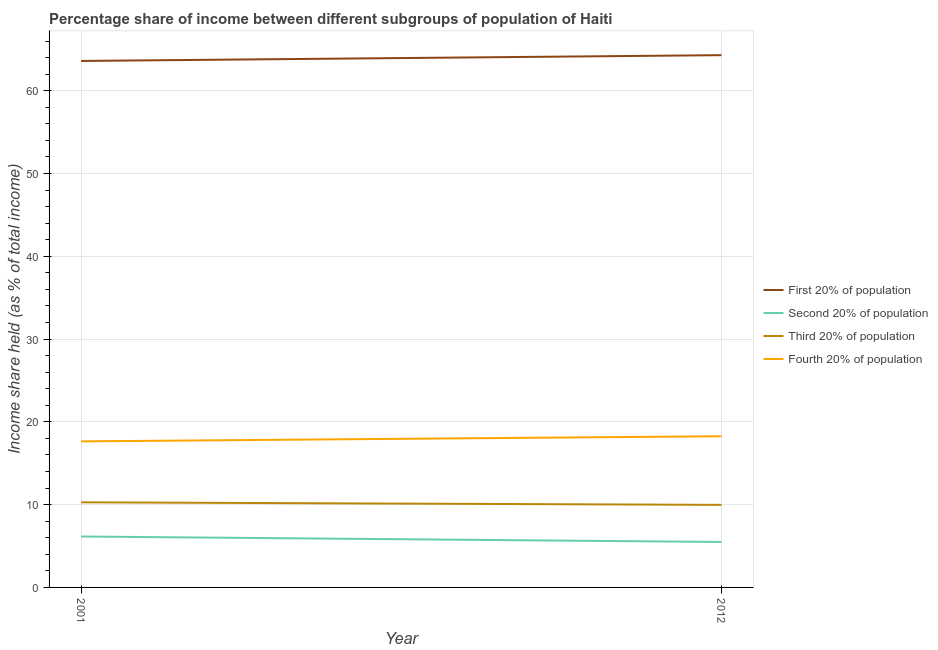Is the number of lines equal to the number of legend labels?
Your answer should be very brief. Yes. What is the share of the income held by first 20% of the population in 2001?
Offer a very short reply. 63.59. Across all years, what is the maximum share of the income held by third 20% of the population?
Your response must be concise. 10.28. Across all years, what is the minimum share of the income held by fourth 20% of the population?
Offer a terse response. 17.64. In which year was the share of the income held by fourth 20% of the population maximum?
Make the answer very short. 2012. In which year was the share of the income held by first 20% of the population minimum?
Keep it short and to the point. 2001. What is the total share of the income held by second 20% of the population in the graph?
Provide a succinct answer. 11.64. What is the difference between the share of the income held by third 20% of the population in 2001 and that in 2012?
Your response must be concise. 0.31. What is the difference between the share of the income held by first 20% of the population in 2001 and the share of the income held by fourth 20% of the population in 2012?
Your answer should be very brief. 45.33. What is the average share of the income held by third 20% of the population per year?
Make the answer very short. 10.12. In the year 2001, what is the difference between the share of the income held by second 20% of the population and share of the income held by first 20% of the population?
Offer a terse response. -57.44. In how many years, is the share of the income held by second 20% of the population greater than 60 %?
Keep it short and to the point. 0. What is the ratio of the share of the income held by second 20% of the population in 2001 to that in 2012?
Make the answer very short. 1.12. Is it the case that in every year, the sum of the share of the income held by first 20% of the population and share of the income held by second 20% of the population is greater than the share of the income held by third 20% of the population?
Make the answer very short. Yes. Does the share of the income held by second 20% of the population monotonically increase over the years?
Your answer should be very brief. No. How many lines are there?
Your answer should be compact. 4. How many years are there in the graph?
Provide a short and direct response. 2. Does the graph contain grids?
Offer a terse response. Yes. How many legend labels are there?
Offer a very short reply. 4. What is the title of the graph?
Provide a short and direct response. Percentage share of income between different subgroups of population of Haiti. What is the label or title of the Y-axis?
Make the answer very short. Income share held (as % of total income). What is the Income share held (as % of total income) of First 20% of population in 2001?
Your answer should be compact. 63.59. What is the Income share held (as % of total income) in Second 20% of population in 2001?
Provide a short and direct response. 6.15. What is the Income share held (as % of total income) of Third 20% of population in 2001?
Give a very brief answer. 10.28. What is the Income share held (as % of total income) in Fourth 20% of population in 2001?
Offer a very short reply. 17.64. What is the Income share held (as % of total income) in First 20% of population in 2012?
Offer a terse response. 64.29. What is the Income share held (as % of total income) of Second 20% of population in 2012?
Give a very brief answer. 5.49. What is the Income share held (as % of total income) in Third 20% of population in 2012?
Give a very brief answer. 9.97. What is the Income share held (as % of total income) in Fourth 20% of population in 2012?
Offer a very short reply. 18.26. Across all years, what is the maximum Income share held (as % of total income) in First 20% of population?
Keep it short and to the point. 64.29. Across all years, what is the maximum Income share held (as % of total income) of Second 20% of population?
Your answer should be very brief. 6.15. Across all years, what is the maximum Income share held (as % of total income) in Third 20% of population?
Your response must be concise. 10.28. Across all years, what is the maximum Income share held (as % of total income) in Fourth 20% of population?
Provide a succinct answer. 18.26. Across all years, what is the minimum Income share held (as % of total income) in First 20% of population?
Offer a very short reply. 63.59. Across all years, what is the minimum Income share held (as % of total income) of Second 20% of population?
Provide a succinct answer. 5.49. Across all years, what is the minimum Income share held (as % of total income) in Third 20% of population?
Your answer should be very brief. 9.97. Across all years, what is the minimum Income share held (as % of total income) of Fourth 20% of population?
Keep it short and to the point. 17.64. What is the total Income share held (as % of total income) in First 20% of population in the graph?
Keep it short and to the point. 127.88. What is the total Income share held (as % of total income) in Second 20% of population in the graph?
Offer a very short reply. 11.64. What is the total Income share held (as % of total income) of Third 20% of population in the graph?
Make the answer very short. 20.25. What is the total Income share held (as % of total income) in Fourth 20% of population in the graph?
Your answer should be very brief. 35.9. What is the difference between the Income share held (as % of total income) of First 20% of population in 2001 and that in 2012?
Ensure brevity in your answer.  -0.7. What is the difference between the Income share held (as % of total income) in Second 20% of population in 2001 and that in 2012?
Provide a succinct answer. 0.66. What is the difference between the Income share held (as % of total income) in Third 20% of population in 2001 and that in 2012?
Offer a terse response. 0.31. What is the difference between the Income share held (as % of total income) of Fourth 20% of population in 2001 and that in 2012?
Make the answer very short. -0.62. What is the difference between the Income share held (as % of total income) in First 20% of population in 2001 and the Income share held (as % of total income) in Second 20% of population in 2012?
Make the answer very short. 58.1. What is the difference between the Income share held (as % of total income) in First 20% of population in 2001 and the Income share held (as % of total income) in Third 20% of population in 2012?
Your response must be concise. 53.62. What is the difference between the Income share held (as % of total income) in First 20% of population in 2001 and the Income share held (as % of total income) in Fourth 20% of population in 2012?
Your answer should be compact. 45.33. What is the difference between the Income share held (as % of total income) of Second 20% of population in 2001 and the Income share held (as % of total income) of Third 20% of population in 2012?
Your answer should be very brief. -3.82. What is the difference between the Income share held (as % of total income) in Second 20% of population in 2001 and the Income share held (as % of total income) in Fourth 20% of population in 2012?
Offer a very short reply. -12.11. What is the difference between the Income share held (as % of total income) of Third 20% of population in 2001 and the Income share held (as % of total income) of Fourth 20% of population in 2012?
Provide a short and direct response. -7.98. What is the average Income share held (as % of total income) in First 20% of population per year?
Provide a short and direct response. 63.94. What is the average Income share held (as % of total income) in Second 20% of population per year?
Offer a very short reply. 5.82. What is the average Income share held (as % of total income) of Third 20% of population per year?
Give a very brief answer. 10.12. What is the average Income share held (as % of total income) in Fourth 20% of population per year?
Keep it short and to the point. 17.95. In the year 2001, what is the difference between the Income share held (as % of total income) in First 20% of population and Income share held (as % of total income) in Second 20% of population?
Your response must be concise. 57.44. In the year 2001, what is the difference between the Income share held (as % of total income) in First 20% of population and Income share held (as % of total income) in Third 20% of population?
Your answer should be compact. 53.31. In the year 2001, what is the difference between the Income share held (as % of total income) of First 20% of population and Income share held (as % of total income) of Fourth 20% of population?
Ensure brevity in your answer.  45.95. In the year 2001, what is the difference between the Income share held (as % of total income) in Second 20% of population and Income share held (as % of total income) in Third 20% of population?
Offer a very short reply. -4.13. In the year 2001, what is the difference between the Income share held (as % of total income) in Second 20% of population and Income share held (as % of total income) in Fourth 20% of population?
Give a very brief answer. -11.49. In the year 2001, what is the difference between the Income share held (as % of total income) of Third 20% of population and Income share held (as % of total income) of Fourth 20% of population?
Your response must be concise. -7.36. In the year 2012, what is the difference between the Income share held (as % of total income) of First 20% of population and Income share held (as % of total income) of Second 20% of population?
Keep it short and to the point. 58.8. In the year 2012, what is the difference between the Income share held (as % of total income) of First 20% of population and Income share held (as % of total income) of Third 20% of population?
Give a very brief answer. 54.32. In the year 2012, what is the difference between the Income share held (as % of total income) in First 20% of population and Income share held (as % of total income) in Fourth 20% of population?
Ensure brevity in your answer.  46.03. In the year 2012, what is the difference between the Income share held (as % of total income) of Second 20% of population and Income share held (as % of total income) of Third 20% of population?
Ensure brevity in your answer.  -4.48. In the year 2012, what is the difference between the Income share held (as % of total income) in Second 20% of population and Income share held (as % of total income) in Fourth 20% of population?
Offer a terse response. -12.77. In the year 2012, what is the difference between the Income share held (as % of total income) in Third 20% of population and Income share held (as % of total income) in Fourth 20% of population?
Your response must be concise. -8.29. What is the ratio of the Income share held (as % of total income) in First 20% of population in 2001 to that in 2012?
Your answer should be compact. 0.99. What is the ratio of the Income share held (as % of total income) of Second 20% of population in 2001 to that in 2012?
Provide a succinct answer. 1.12. What is the ratio of the Income share held (as % of total income) of Third 20% of population in 2001 to that in 2012?
Give a very brief answer. 1.03. What is the ratio of the Income share held (as % of total income) in Fourth 20% of population in 2001 to that in 2012?
Keep it short and to the point. 0.97. What is the difference between the highest and the second highest Income share held (as % of total income) of First 20% of population?
Your answer should be compact. 0.7. What is the difference between the highest and the second highest Income share held (as % of total income) of Second 20% of population?
Your answer should be very brief. 0.66. What is the difference between the highest and the second highest Income share held (as % of total income) of Third 20% of population?
Give a very brief answer. 0.31. What is the difference between the highest and the second highest Income share held (as % of total income) in Fourth 20% of population?
Keep it short and to the point. 0.62. What is the difference between the highest and the lowest Income share held (as % of total income) of Second 20% of population?
Give a very brief answer. 0.66. What is the difference between the highest and the lowest Income share held (as % of total income) of Third 20% of population?
Give a very brief answer. 0.31. What is the difference between the highest and the lowest Income share held (as % of total income) of Fourth 20% of population?
Ensure brevity in your answer.  0.62. 